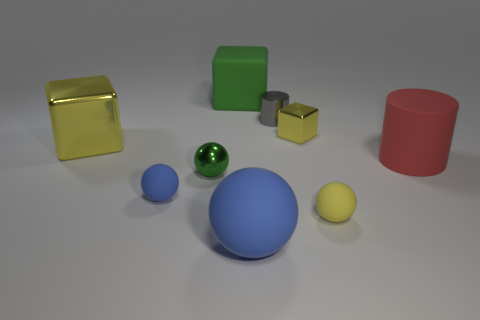Is the tiny cylinder made of the same material as the big thing right of the small cube?
Offer a terse response. No. Is there a small blue thing of the same shape as the small gray shiny object?
Ensure brevity in your answer.  No. What material is the blue ball that is the same size as the yellow rubber sphere?
Offer a very short reply. Rubber. There is a yellow thing in front of the red cylinder; what is its size?
Offer a very short reply. Small. Does the yellow shiny thing that is right of the small gray object have the same size as the yellow shiny object on the left side of the green matte cube?
Ensure brevity in your answer.  No. How many cubes are made of the same material as the big ball?
Keep it short and to the point. 1. The large matte block is what color?
Make the answer very short. Green. Are there any tiny yellow rubber things behind the red object?
Your answer should be compact. No. Does the big matte sphere have the same color as the big cylinder?
Offer a terse response. No. What number of metal cubes are the same color as the big rubber cube?
Your answer should be very brief. 0. 